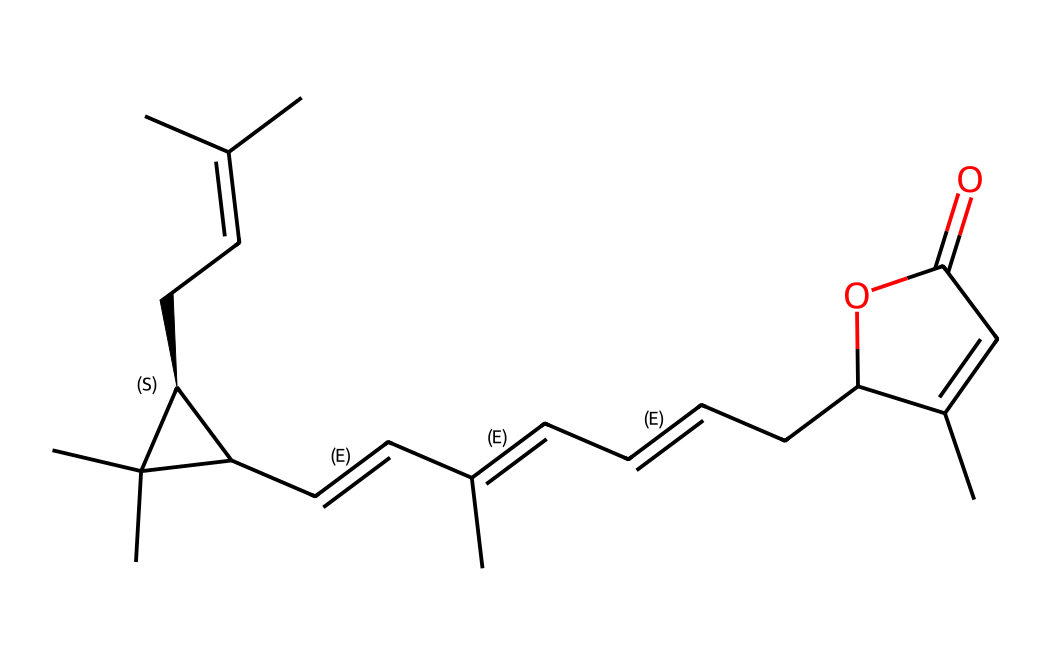What is the molecular formula for pyrethrin? To find the molecular formula, we need to count the number of each type of atom present in the SMILES representation. The given SMILES indicates the presence of carbon (C), hydrogen (H), and oxygen (O) atoms. Through analysis, we can determine the molecular formula to be C21H28O5.
Answer: C21H28O5 How many rings are present in this molecule? Examining the structure in the SMILES, we can identify the cyclic structures represented by the numbers around the atoms. Here we see two ring structures indicated by 'C1' and 'C2'. Thus, there are two rings in total.
Answer: 2 What type of compound is pyrethrin? Based on its natural derivation from chrysanthemum flowers and its functionality as an insecticide, this compound is classified as a natural pesticide.
Answer: natural pesticide How many double bonds are present in the structure? The SMILES representation shows several instances of 'C=C', indicating double bonds. By closely analyzing the structure, we find that there are four double bonds present throughout the molecule.
Answer: 4 What functional group is primarily represented in pyrethrin? The presence of the carbonyl group (C=O) in the structure indicates that pyrethrin contains an ester functional group, specifically linking an alcohol and a carboxylic acid. This characteristic defines its reactivity and properties as an insecticide.
Answer: ester What is the role of pyrethrin in pest control? Pyrethrin acts as a neurotoxin to insects by disrupting their nervous system functions, leading to paralysis and death. It is effective against many pests, making it a popular choice in pest control products.
Answer: neurotoxin 